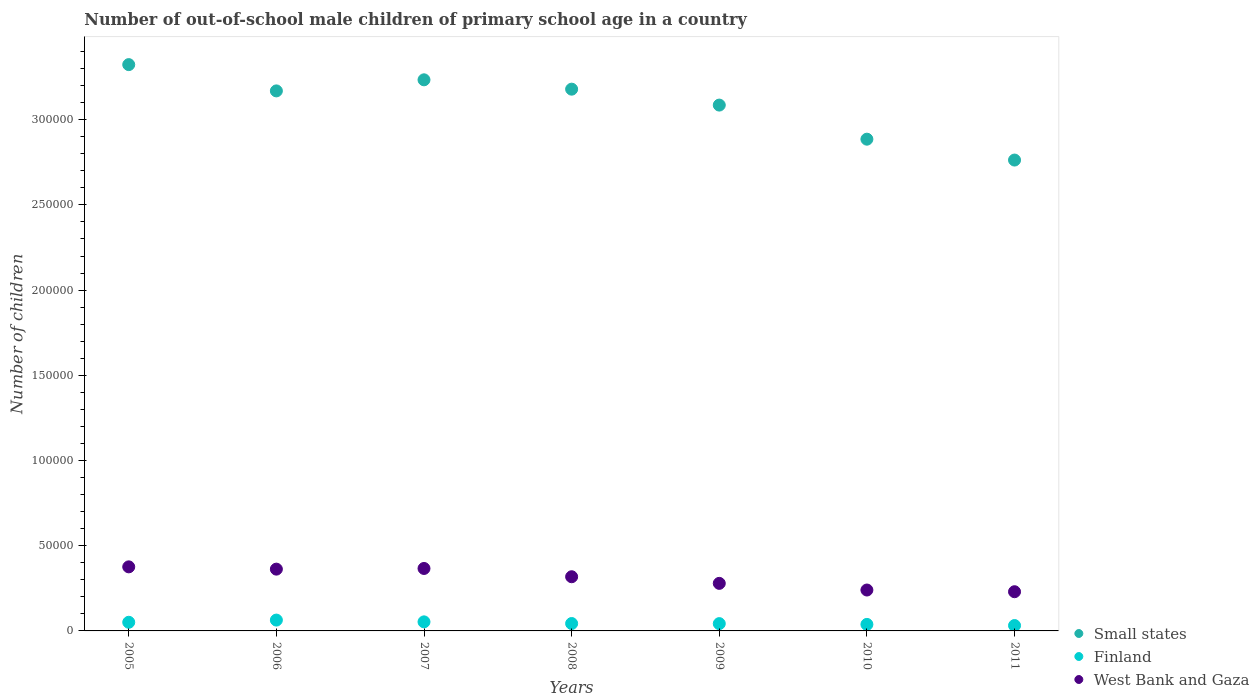What is the number of out-of-school male children in Small states in 2005?
Provide a short and direct response. 3.32e+05. Across all years, what is the maximum number of out-of-school male children in Small states?
Provide a succinct answer. 3.32e+05. Across all years, what is the minimum number of out-of-school male children in West Bank and Gaza?
Ensure brevity in your answer.  2.30e+04. In which year was the number of out-of-school male children in Small states minimum?
Provide a short and direct response. 2011. What is the total number of out-of-school male children in Small states in the graph?
Your answer should be very brief. 2.16e+06. What is the difference between the number of out-of-school male children in Small states in 2005 and that in 2007?
Your answer should be very brief. 8917. What is the difference between the number of out-of-school male children in West Bank and Gaza in 2006 and the number of out-of-school male children in Small states in 2007?
Give a very brief answer. -2.87e+05. What is the average number of out-of-school male children in West Bank and Gaza per year?
Offer a terse response. 3.10e+04. In the year 2007, what is the difference between the number of out-of-school male children in Finland and number of out-of-school male children in West Bank and Gaza?
Your response must be concise. -3.13e+04. In how many years, is the number of out-of-school male children in West Bank and Gaza greater than 190000?
Ensure brevity in your answer.  0. What is the ratio of the number of out-of-school male children in Finland in 2010 to that in 2011?
Keep it short and to the point. 1.21. What is the difference between the highest and the second highest number of out-of-school male children in Small states?
Offer a terse response. 8917. What is the difference between the highest and the lowest number of out-of-school male children in West Bank and Gaza?
Your answer should be compact. 1.46e+04. In how many years, is the number of out-of-school male children in West Bank and Gaza greater than the average number of out-of-school male children in West Bank and Gaza taken over all years?
Your answer should be very brief. 4. Does the number of out-of-school male children in Finland monotonically increase over the years?
Your response must be concise. No. Is the number of out-of-school male children in West Bank and Gaza strictly greater than the number of out-of-school male children in Finland over the years?
Ensure brevity in your answer.  Yes. How many dotlines are there?
Your answer should be compact. 3. Does the graph contain any zero values?
Keep it short and to the point. No. Does the graph contain grids?
Offer a terse response. No. How many legend labels are there?
Your answer should be compact. 3. How are the legend labels stacked?
Provide a short and direct response. Vertical. What is the title of the graph?
Provide a succinct answer. Number of out-of-school male children of primary school age in a country. What is the label or title of the Y-axis?
Keep it short and to the point. Number of children. What is the Number of children of Small states in 2005?
Make the answer very short. 3.32e+05. What is the Number of children in Finland in 2005?
Ensure brevity in your answer.  5074. What is the Number of children of West Bank and Gaza in 2005?
Your answer should be compact. 3.76e+04. What is the Number of children in Small states in 2006?
Keep it short and to the point. 3.17e+05. What is the Number of children in Finland in 2006?
Your answer should be very brief. 6361. What is the Number of children in West Bank and Gaza in 2006?
Provide a succinct answer. 3.63e+04. What is the Number of children in Small states in 2007?
Your answer should be very brief. 3.23e+05. What is the Number of children of Finland in 2007?
Give a very brief answer. 5317. What is the Number of children of West Bank and Gaza in 2007?
Give a very brief answer. 3.66e+04. What is the Number of children in Small states in 2008?
Offer a very short reply. 3.18e+05. What is the Number of children in Finland in 2008?
Your answer should be compact. 4339. What is the Number of children in West Bank and Gaza in 2008?
Offer a very short reply. 3.18e+04. What is the Number of children in Small states in 2009?
Keep it short and to the point. 3.09e+05. What is the Number of children in Finland in 2009?
Give a very brief answer. 4284. What is the Number of children in West Bank and Gaza in 2009?
Offer a very short reply. 2.79e+04. What is the Number of children of Small states in 2010?
Your answer should be compact. 2.89e+05. What is the Number of children of Finland in 2010?
Provide a succinct answer. 3820. What is the Number of children in West Bank and Gaza in 2010?
Make the answer very short. 2.40e+04. What is the Number of children in Small states in 2011?
Ensure brevity in your answer.  2.76e+05. What is the Number of children in Finland in 2011?
Your response must be concise. 3159. What is the Number of children in West Bank and Gaza in 2011?
Your answer should be compact. 2.30e+04. Across all years, what is the maximum Number of children of Small states?
Ensure brevity in your answer.  3.32e+05. Across all years, what is the maximum Number of children of Finland?
Your answer should be very brief. 6361. Across all years, what is the maximum Number of children in West Bank and Gaza?
Give a very brief answer. 3.76e+04. Across all years, what is the minimum Number of children in Small states?
Make the answer very short. 2.76e+05. Across all years, what is the minimum Number of children of Finland?
Ensure brevity in your answer.  3159. Across all years, what is the minimum Number of children in West Bank and Gaza?
Keep it short and to the point. 2.30e+04. What is the total Number of children of Small states in the graph?
Give a very brief answer. 2.16e+06. What is the total Number of children in Finland in the graph?
Offer a terse response. 3.24e+04. What is the total Number of children in West Bank and Gaza in the graph?
Give a very brief answer. 2.17e+05. What is the difference between the Number of children of Small states in 2005 and that in 2006?
Your answer should be compact. 1.54e+04. What is the difference between the Number of children of Finland in 2005 and that in 2006?
Your answer should be very brief. -1287. What is the difference between the Number of children in West Bank and Gaza in 2005 and that in 2006?
Offer a very short reply. 1339. What is the difference between the Number of children of Small states in 2005 and that in 2007?
Provide a succinct answer. 8917. What is the difference between the Number of children in Finland in 2005 and that in 2007?
Your response must be concise. -243. What is the difference between the Number of children of West Bank and Gaza in 2005 and that in 2007?
Provide a short and direct response. 946. What is the difference between the Number of children in Small states in 2005 and that in 2008?
Your answer should be compact. 1.44e+04. What is the difference between the Number of children in Finland in 2005 and that in 2008?
Offer a terse response. 735. What is the difference between the Number of children in West Bank and Gaza in 2005 and that in 2008?
Provide a succinct answer. 5803. What is the difference between the Number of children in Small states in 2005 and that in 2009?
Give a very brief answer. 2.37e+04. What is the difference between the Number of children of Finland in 2005 and that in 2009?
Offer a very short reply. 790. What is the difference between the Number of children in West Bank and Gaza in 2005 and that in 2009?
Give a very brief answer. 9686. What is the difference between the Number of children of Small states in 2005 and that in 2010?
Your response must be concise. 4.38e+04. What is the difference between the Number of children in Finland in 2005 and that in 2010?
Ensure brevity in your answer.  1254. What is the difference between the Number of children in West Bank and Gaza in 2005 and that in 2010?
Keep it short and to the point. 1.36e+04. What is the difference between the Number of children of Small states in 2005 and that in 2011?
Your answer should be very brief. 5.60e+04. What is the difference between the Number of children in Finland in 2005 and that in 2011?
Keep it short and to the point. 1915. What is the difference between the Number of children of West Bank and Gaza in 2005 and that in 2011?
Keep it short and to the point. 1.46e+04. What is the difference between the Number of children in Small states in 2006 and that in 2007?
Provide a short and direct response. -6503. What is the difference between the Number of children of Finland in 2006 and that in 2007?
Your answer should be compact. 1044. What is the difference between the Number of children in West Bank and Gaza in 2006 and that in 2007?
Your answer should be compact. -393. What is the difference between the Number of children of Small states in 2006 and that in 2008?
Your response must be concise. -1017. What is the difference between the Number of children of Finland in 2006 and that in 2008?
Your answer should be very brief. 2022. What is the difference between the Number of children of West Bank and Gaza in 2006 and that in 2008?
Offer a terse response. 4464. What is the difference between the Number of children in Small states in 2006 and that in 2009?
Ensure brevity in your answer.  8329. What is the difference between the Number of children in Finland in 2006 and that in 2009?
Keep it short and to the point. 2077. What is the difference between the Number of children of West Bank and Gaza in 2006 and that in 2009?
Offer a terse response. 8347. What is the difference between the Number of children of Small states in 2006 and that in 2010?
Keep it short and to the point. 2.83e+04. What is the difference between the Number of children in Finland in 2006 and that in 2010?
Your response must be concise. 2541. What is the difference between the Number of children in West Bank and Gaza in 2006 and that in 2010?
Provide a short and direct response. 1.23e+04. What is the difference between the Number of children of Small states in 2006 and that in 2011?
Give a very brief answer. 4.06e+04. What is the difference between the Number of children of Finland in 2006 and that in 2011?
Offer a very short reply. 3202. What is the difference between the Number of children of West Bank and Gaza in 2006 and that in 2011?
Your response must be concise. 1.33e+04. What is the difference between the Number of children in Small states in 2007 and that in 2008?
Make the answer very short. 5486. What is the difference between the Number of children in Finland in 2007 and that in 2008?
Ensure brevity in your answer.  978. What is the difference between the Number of children of West Bank and Gaza in 2007 and that in 2008?
Provide a succinct answer. 4857. What is the difference between the Number of children in Small states in 2007 and that in 2009?
Offer a terse response. 1.48e+04. What is the difference between the Number of children of Finland in 2007 and that in 2009?
Your answer should be compact. 1033. What is the difference between the Number of children of West Bank and Gaza in 2007 and that in 2009?
Provide a succinct answer. 8740. What is the difference between the Number of children of Small states in 2007 and that in 2010?
Ensure brevity in your answer.  3.48e+04. What is the difference between the Number of children in Finland in 2007 and that in 2010?
Provide a succinct answer. 1497. What is the difference between the Number of children of West Bank and Gaza in 2007 and that in 2010?
Ensure brevity in your answer.  1.26e+04. What is the difference between the Number of children of Small states in 2007 and that in 2011?
Keep it short and to the point. 4.71e+04. What is the difference between the Number of children in Finland in 2007 and that in 2011?
Your answer should be compact. 2158. What is the difference between the Number of children in West Bank and Gaza in 2007 and that in 2011?
Give a very brief answer. 1.36e+04. What is the difference between the Number of children in Small states in 2008 and that in 2009?
Your response must be concise. 9346. What is the difference between the Number of children in Finland in 2008 and that in 2009?
Your answer should be compact. 55. What is the difference between the Number of children of West Bank and Gaza in 2008 and that in 2009?
Provide a succinct answer. 3883. What is the difference between the Number of children of Small states in 2008 and that in 2010?
Provide a short and direct response. 2.93e+04. What is the difference between the Number of children of Finland in 2008 and that in 2010?
Keep it short and to the point. 519. What is the difference between the Number of children in West Bank and Gaza in 2008 and that in 2010?
Your answer should be compact. 7791. What is the difference between the Number of children in Small states in 2008 and that in 2011?
Keep it short and to the point. 4.16e+04. What is the difference between the Number of children of Finland in 2008 and that in 2011?
Offer a terse response. 1180. What is the difference between the Number of children in West Bank and Gaza in 2008 and that in 2011?
Your answer should be very brief. 8790. What is the difference between the Number of children in Small states in 2009 and that in 2010?
Keep it short and to the point. 2.00e+04. What is the difference between the Number of children of Finland in 2009 and that in 2010?
Provide a short and direct response. 464. What is the difference between the Number of children in West Bank and Gaza in 2009 and that in 2010?
Keep it short and to the point. 3908. What is the difference between the Number of children in Small states in 2009 and that in 2011?
Ensure brevity in your answer.  3.23e+04. What is the difference between the Number of children of Finland in 2009 and that in 2011?
Provide a short and direct response. 1125. What is the difference between the Number of children in West Bank and Gaza in 2009 and that in 2011?
Offer a very short reply. 4907. What is the difference between the Number of children in Small states in 2010 and that in 2011?
Ensure brevity in your answer.  1.22e+04. What is the difference between the Number of children in Finland in 2010 and that in 2011?
Give a very brief answer. 661. What is the difference between the Number of children of West Bank and Gaza in 2010 and that in 2011?
Provide a short and direct response. 999. What is the difference between the Number of children of Small states in 2005 and the Number of children of Finland in 2006?
Provide a succinct answer. 3.26e+05. What is the difference between the Number of children of Small states in 2005 and the Number of children of West Bank and Gaza in 2006?
Provide a succinct answer. 2.96e+05. What is the difference between the Number of children in Finland in 2005 and the Number of children in West Bank and Gaza in 2006?
Offer a terse response. -3.12e+04. What is the difference between the Number of children in Small states in 2005 and the Number of children in Finland in 2007?
Provide a succinct answer. 3.27e+05. What is the difference between the Number of children in Small states in 2005 and the Number of children in West Bank and Gaza in 2007?
Keep it short and to the point. 2.96e+05. What is the difference between the Number of children of Finland in 2005 and the Number of children of West Bank and Gaza in 2007?
Your answer should be compact. -3.16e+04. What is the difference between the Number of children in Small states in 2005 and the Number of children in Finland in 2008?
Ensure brevity in your answer.  3.28e+05. What is the difference between the Number of children in Small states in 2005 and the Number of children in West Bank and Gaza in 2008?
Provide a succinct answer. 3.01e+05. What is the difference between the Number of children in Finland in 2005 and the Number of children in West Bank and Gaza in 2008?
Provide a short and direct response. -2.67e+04. What is the difference between the Number of children of Small states in 2005 and the Number of children of Finland in 2009?
Offer a very short reply. 3.28e+05. What is the difference between the Number of children in Small states in 2005 and the Number of children in West Bank and Gaza in 2009?
Provide a succinct answer. 3.04e+05. What is the difference between the Number of children in Finland in 2005 and the Number of children in West Bank and Gaza in 2009?
Give a very brief answer. -2.28e+04. What is the difference between the Number of children in Small states in 2005 and the Number of children in Finland in 2010?
Give a very brief answer. 3.28e+05. What is the difference between the Number of children of Small states in 2005 and the Number of children of West Bank and Gaza in 2010?
Ensure brevity in your answer.  3.08e+05. What is the difference between the Number of children of Finland in 2005 and the Number of children of West Bank and Gaza in 2010?
Your answer should be very brief. -1.89e+04. What is the difference between the Number of children in Small states in 2005 and the Number of children in Finland in 2011?
Ensure brevity in your answer.  3.29e+05. What is the difference between the Number of children of Small states in 2005 and the Number of children of West Bank and Gaza in 2011?
Provide a succinct answer. 3.09e+05. What is the difference between the Number of children in Finland in 2005 and the Number of children in West Bank and Gaza in 2011?
Provide a short and direct response. -1.79e+04. What is the difference between the Number of children in Small states in 2006 and the Number of children in Finland in 2007?
Give a very brief answer. 3.12e+05. What is the difference between the Number of children of Small states in 2006 and the Number of children of West Bank and Gaza in 2007?
Your response must be concise. 2.80e+05. What is the difference between the Number of children in Finland in 2006 and the Number of children in West Bank and Gaza in 2007?
Provide a succinct answer. -3.03e+04. What is the difference between the Number of children in Small states in 2006 and the Number of children in Finland in 2008?
Ensure brevity in your answer.  3.13e+05. What is the difference between the Number of children of Small states in 2006 and the Number of children of West Bank and Gaza in 2008?
Your answer should be compact. 2.85e+05. What is the difference between the Number of children of Finland in 2006 and the Number of children of West Bank and Gaza in 2008?
Provide a succinct answer. -2.54e+04. What is the difference between the Number of children of Small states in 2006 and the Number of children of Finland in 2009?
Provide a succinct answer. 3.13e+05. What is the difference between the Number of children in Small states in 2006 and the Number of children in West Bank and Gaza in 2009?
Your answer should be compact. 2.89e+05. What is the difference between the Number of children of Finland in 2006 and the Number of children of West Bank and Gaza in 2009?
Offer a terse response. -2.15e+04. What is the difference between the Number of children of Small states in 2006 and the Number of children of Finland in 2010?
Give a very brief answer. 3.13e+05. What is the difference between the Number of children in Small states in 2006 and the Number of children in West Bank and Gaza in 2010?
Your answer should be very brief. 2.93e+05. What is the difference between the Number of children in Finland in 2006 and the Number of children in West Bank and Gaza in 2010?
Make the answer very short. -1.76e+04. What is the difference between the Number of children of Small states in 2006 and the Number of children of Finland in 2011?
Make the answer very short. 3.14e+05. What is the difference between the Number of children of Small states in 2006 and the Number of children of West Bank and Gaza in 2011?
Offer a very short reply. 2.94e+05. What is the difference between the Number of children in Finland in 2006 and the Number of children in West Bank and Gaza in 2011?
Ensure brevity in your answer.  -1.66e+04. What is the difference between the Number of children in Small states in 2007 and the Number of children in Finland in 2008?
Offer a very short reply. 3.19e+05. What is the difference between the Number of children in Small states in 2007 and the Number of children in West Bank and Gaza in 2008?
Offer a very short reply. 2.92e+05. What is the difference between the Number of children in Finland in 2007 and the Number of children in West Bank and Gaza in 2008?
Your answer should be very brief. -2.65e+04. What is the difference between the Number of children of Small states in 2007 and the Number of children of Finland in 2009?
Provide a succinct answer. 3.19e+05. What is the difference between the Number of children in Small states in 2007 and the Number of children in West Bank and Gaza in 2009?
Give a very brief answer. 2.95e+05. What is the difference between the Number of children in Finland in 2007 and the Number of children in West Bank and Gaza in 2009?
Provide a short and direct response. -2.26e+04. What is the difference between the Number of children of Small states in 2007 and the Number of children of Finland in 2010?
Offer a terse response. 3.20e+05. What is the difference between the Number of children of Small states in 2007 and the Number of children of West Bank and Gaza in 2010?
Keep it short and to the point. 2.99e+05. What is the difference between the Number of children in Finland in 2007 and the Number of children in West Bank and Gaza in 2010?
Offer a very short reply. -1.87e+04. What is the difference between the Number of children of Small states in 2007 and the Number of children of Finland in 2011?
Your answer should be very brief. 3.20e+05. What is the difference between the Number of children of Small states in 2007 and the Number of children of West Bank and Gaza in 2011?
Keep it short and to the point. 3.00e+05. What is the difference between the Number of children in Finland in 2007 and the Number of children in West Bank and Gaza in 2011?
Offer a very short reply. -1.77e+04. What is the difference between the Number of children in Small states in 2008 and the Number of children in Finland in 2009?
Your answer should be compact. 3.14e+05. What is the difference between the Number of children in Small states in 2008 and the Number of children in West Bank and Gaza in 2009?
Keep it short and to the point. 2.90e+05. What is the difference between the Number of children in Finland in 2008 and the Number of children in West Bank and Gaza in 2009?
Offer a terse response. -2.36e+04. What is the difference between the Number of children in Small states in 2008 and the Number of children in Finland in 2010?
Your answer should be compact. 3.14e+05. What is the difference between the Number of children of Small states in 2008 and the Number of children of West Bank and Gaza in 2010?
Ensure brevity in your answer.  2.94e+05. What is the difference between the Number of children in Finland in 2008 and the Number of children in West Bank and Gaza in 2010?
Your response must be concise. -1.97e+04. What is the difference between the Number of children in Small states in 2008 and the Number of children in Finland in 2011?
Ensure brevity in your answer.  3.15e+05. What is the difference between the Number of children of Small states in 2008 and the Number of children of West Bank and Gaza in 2011?
Provide a succinct answer. 2.95e+05. What is the difference between the Number of children of Finland in 2008 and the Number of children of West Bank and Gaza in 2011?
Your answer should be very brief. -1.87e+04. What is the difference between the Number of children in Small states in 2009 and the Number of children in Finland in 2010?
Provide a short and direct response. 3.05e+05. What is the difference between the Number of children of Small states in 2009 and the Number of children of West Bank and Gaza in 2010?
Make the answer very short. 2.85e+05. What is the difference between the Number of children in Finland in 2009 and the Number of children in West Bank and Gaza in 2010?
Your answer should be compact. -1.97e+04. What is the difference between the Number of children in Small states in 2009 and the Number of children in Finland in 2011?
Your answer should be compact. 3.05e+05. What is the difference between the Number of children of Small states in 2009 and the Number of children of West Bank and Gaza in 2011?
Give a very brief answer. 2.86e+05. What is the difference between the Number of children of Finland in 2009 and the Number of children of West Bank and Gaza in 2011?
Provide a short and direct response. -1.87e+04. What is the difference between the Number of children in Small states in 2010 and the Number of children in Finland in 2011?
Your response must be concise. 2.85e+05. What is the difference between the Number of children of Small states in 2010 and the Number of children of West Bank and Gaza in 2011?
Ensure brevity in your answer.  2.66e+05. What is the difference between the Number of children of Finland in 2010 and the Number of children of West Bank and Gaza in 2011?
Give a very brief answer. -1.92e+04. What is the average Number of children of Small states per year?
Provide a succinct answer. 3.09e+05. What is the average Number of children in Finland per year?
Your response must be concise. 4622. What is the average Number of children in West Bank and Gaza per year?
Your answer should be very brief. 3.10e+04. In the year 2005, what is the difference between the Number of children of Small states and Number of children of Finland?
Give a very brief answer. 3.27e+05. In the year 2005, what is the difference between the Number of children of Small states and Number of children of West Bank and Gaza?
Provide a short and direct response. 2.95e+05. In the year 2005, what is the difference between the Number of children in Finland and Number of children in West Bank and Gaza?
Make the answer very short. -3.25e+04. In the year 2006, what is the difference between the Number of children of Small states and Number of children of Finland?
Make the answer very short. 3.11e+05. In the year 2006, what is the difference between the Number of children of Small states and Number of children of West Bank and Gaza?
Keep it short and to the point. 2.81e+05. In the year 2006, what is the difference between the Number of children in Finland and Number of children in West Bank and Gaza?
Offer a terse response. -2.99e+04. In the year 2007, what is the difference between the Number of children of Small states and Number of children of Finland?
Your response must be concise. 3.18e+05. In the year 2007, what is the difference between the Number of children in Small states and Number of children in West Bank and Gaza?
Keep it short and to the point. 2.87e+05. In the year 2007, what is the difference between the Number of children in Finland and Number of children in West Bank and Gaza?
Provide a short and direct response. -3.13e+04. In the year 2008, what is the difference between the Number of children of Small states and Number of children of Finland?
Your response must be concise. 3.14e+05. In the year 2008, what is the difference between the Number of children in Small states and Number of children in West Bank and Gaza?
Offer a terse response. 2.86e+05. In the year 2008, what is the difference between the Number of children in Finland and Number of children in West Bank and Gaza?
Your answer should be compact. -2.75e+04. In the year 2009, what is the difference between the Number of children in Small states and Number of children in Finland?
Your answer should be compact. 3.04e+05. In the year 2009, what is the difference between the Number of children of Small states and Number of children of West Bank and Gaza?
Your answer should be very brief. 2.81e+05. In the year 2009, what is the difference between the Number of children of Finland and Number of children of West Bank and Gaza?
Ensure brevity in your answer.  -2.36e+04. In the year 2010, what is the difference between the Number of children of Small states and Number of children of Finland?
Keep it short and to the point. 2.85e+05. In the year 2010, what is the difference between the Number of children in Small states and Number of children in West Bank and Gaza?
Make the answer very short. 2.65e+05. In the year 2010, what is the difference between the Number of children of Finland and Number of children of West Bank and Gaza?
Keep it short and to the point. -2.02e+04. In the year 2011, what is the difference between the Number of children in Small states and Number of children in Finland?
Give a very brief answer. 2.73e+05. In the year 2011, what is the difference between the Number of children in Small states and Number of children in West Bank and Gaza?
Offer a terse response. 2.53e+05. In the year 2011, what is the difference between the Number of children of Finland and Number of children of West Bank and Gaza?
Keep it short and to the point. -1.98e+04. What is the ratio of the Number of children of Small states in 2005 to that in 2006?
Your response must be concise. 1.05. What is the ratio of the Number of children in Finland in 2005 to that in 2006?
Your response must be concise. 0.8. What is the ratio of the Number of children of West Bank and Gaza in 2005 to that in 2006?
Your response must be concise. 1.04. What is the ratio of the Number of children in Small states in 2005 to that in 2007?
Keep it short and to the point. 1.03. What is the ratio of the Number of children of Finland in 2005 to that in 2007?
Keep it short and to the point. 0.95. What is the ratio of the Number of children in West Bank and Gaza in 2005 to that in 2007?
Provide a short and direct response. 1.03. What is the ratio of the Number of children of Small states in 2005 to that in 2008?
Offer a terse response. 1.05. What is the ratio of the Number of children of Finland in 2005 to that in 2008?
Provide a succinct answer. 1.17. What is the ratio of the Number of children of West Bank and Gaza in 2005 to that in 2008?
Offer a very short reply. 1.18. What is the ratio of the Number of children of Small states in 2005 to that in 2009?
Offer a terse response. 1.08. What is the ratio of the Number of children in Finland in 2005 to that in 2009?
Provide a short and direct response. 1.18. What is the ratio of the Number of children in West Bank and Gaza in 2005 to that in 2009?
Your answer should be compact. 1.35. What is the ratio of the Number of children in Small states in 2005 to that in 2010?
Provide a succinct answer. 1.15. What is the ratio of the Number of children of Finland in 2005 to that in 2010?
Make the answer very short. 1.33. What is the ratio of the Number of children in West Bank and Gaza in 2005 to that in 2010?
Offer a very short reply. 1.57. What is the ratio of the Number of children in Small states in 2005 to that in 2011?
Keep it short and to the point. 1.2. What is the ratio of the Number of children in Finland in 2005 to that in 2011?
Your answer should be very brief. 1.61. What is the ratio of the Number of children of West Bank and Gaza in 2005 to that in 2011?
Ensure brevity in your answer.  1.63. What is the ratio of the Number of children in Small states in 2006 to that in 2007?
Your response must be concise. 0.98. What is the ratio of the Number of children in Finland in 2006 to that in 2007?
Your answer should be very brief. 1.2. What is the ratio of the Number of children in West Bank and Gaza in 2006 to that in 2007?
Your answer should be compact. 0.99. What is the ratio of the Number of children of Finland in 2006 to that in 2008?
Give a very brief answer. 1.47. What is the ratio of the Number of children in West Bank and Gaza in 2006 to that in 2008?
Provide a short and direct response. 1.14. What is the ratio of the Number of children of Finland in 2006 to that in 2009?
Ensure brevity in your answer.  1.48. What is the ratio of the Number of children of West Bank and Gaza in 2006 to that in 2009?
Ensure brevity in your answer.  1.3. What is the ratio of the Number of children of Small states in 2006 to that in 2010?
Your answer should be very brief. 1.1. What is the ratio of the Number of children of Finland in 2006 to that in 2010?
Make the answer very short. 1.67. What is the ratio of the Number of children of West Bank and Gaza in 2006 to that in 2010?
Make the answer very short. 1.51. What is the ratio of the Number of children of Small states in 2006 to that in 2011?
Keep it short and to the point. 1.15. What is the ratio of the Number of children in Finland in 2006 to that in 2011?
Offer a terse response. 2.01. What is the ratio of the Number of children of West Bank and Gaza in 2006 to that in 2011?
Ensure brevity in your answer.  1.58. What is the ratio of the Number of children in Small states in 2007 to that in 2008?
Offer a very short reply. 1.02. What is the ratio of the Number of children of Finland in 2007 to that in 2008?
Offer a very short reply. 1.23. What is the ratio of the Number of children of West Bank and Gaza in 2007 to that in 2008?
Your answer should be compact. 1.15. What is the ratio of the Number of children in Small states in 2007 to that in 2009?
Provide a short and direct response. 1.05. What is the ratio of the Number of children of Finland in 2007 to that in 2009?
Your answer should be compact. 1.24. What is the ratio of the Number of children in West Bank and Gaza in 2007 to that in 2009?
Provide a short and direct response. 1.31. What is the ratio of the Number of children in Small states in 2007 to that in 2010?
Ensure brevity in your answer.  1.12. What is the ratio of the Number of children in Finland in 2007 to that in 2010?
Give a very brief answer. 1.39. What is the ratio of the Number of children in West Bank and Gaza in 2007 to that in 2010?
Provide a short and direct response. 1.53. What is the ratio of the Number of children in Small states in 2007 to that in 2011?
Offer a very short reply. 1.17. What is the ratio of the Number of children in Finland in 2007 to that in 2011?
Give a very brief answer. 1.68. What is the ratio of the Number of children in West Bank and Gaza in 2007 to that in 2011?
Make the answer very short. 1.59. What is the ratio of the Number of children of Small states in 2008 to that in 2009?
Keep it short and to the point. 1.03. What is the ratio of the Number of children of Finland in 2008 to that in 2009?
Ensure brevity in your answer.  1.01. What is the ratio of the Number of children of West Bank and Gaza in 2008 to that in 2009?
Give a very brief answer. 1.14. What is the ratio of the Number of children in Small states in 2008 to that in 2010?
Your response must be concise. 1.1. What is the ratio of the Number of children of Finland in 2008 to that in 2010?
Offer a terse response. 1.14. What is the ratio of the Number of children of West Bank and Gaza in 2008 to that in 2010?
Ensure brevity in your answer.  1.32. What is the ratio of the Number of children of Small states in 2008 to that in 2011?
Give a very brief answer. 1.15. What is the ratio of the Number of children of Finland in 2008 to that in 2011?
Your response must be concise. 1.37. What is the ratio of the Number of children in West Bank and Gaza in 2008 to that in 2011?
Make the answer very short. 1.38. What is the ratio of the Number of children in Small states in 2009 to that in 2010?
Provide a short and direct response. 1.07. What is the ratio of the Number of children of Finland in 2009 to that in 2010?
Provide a short and direct response. 1.12. What is the ratio of the Number of children in West Bank and Gaza in 2009 to that in 2010?
Give a very brief answer. 1.16. What is the ratio of the Number of children in Small states in 2009 to that in 2011?
Keep it short and to the point. 1.12. What is the ratio of the Number of children in Finland in 2009 to that in 2011?
Your response must be concise. 1.36. What is the ratio of the Number of children of West Bank and Gaza in 2009 to that in 2011?
Your response must be concise. 1.21. What is the ratio of the Number of children of Small states in 2010 to that in 2011?
Your answer should be very brief. 1.04. What is the ratio of the Number of children of Finland in 2010 to that in 2011?
Keep it short and to the point. 1.21. What is the ratio of the Number of children in West Bank and Gaza in 2010 to that in 2011?
Offer a very short reply. 1.04. What is the difference between the highest and the second highest Number of children of Small states?
Your response must be concise. 8917. What is the difference between the highest and the second highest Number of children in Finland?
Keep it short and to the point. 1044. What is the difference between the highest and the second highest Number of children in West Bank and Gaza?
Offer a terse response. 946. What is the difference between the highest and the lowest Number of children in Small states?
Make the answer very short. 5.60e+04. What is the difference between the highest and the lowest Number of children in Finland?
Provide a succinct answer. 3202. What is the difference between the highest and the lowest Number of children of West Bank and Gaza?
Provide a short and direct response. 1.46e+04. 